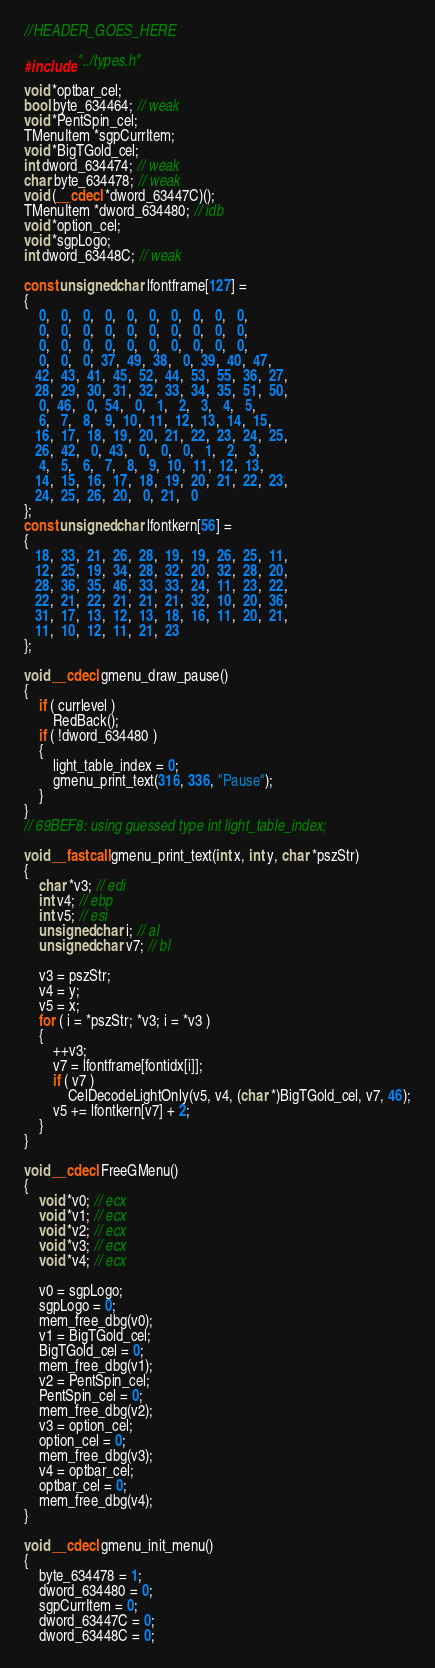<code> <loc_0><loc_0><loc_500><loc_500><_C++_>//HEADER_GOES_HERE

#include "../types.h"

void *optbar_cel;
bool byte_634464; // weak
void *PentSpin_cel;
TMenuItem *sgpCurrItem;
void *BigTGold_cel;
int dword_634474; // weak
char byte_634478; // weak
void (__cdecl *dword_63447C)();
TMenuItem *dword_634480; // idb
void *option_cel;
void *sgpLogo;
int dword_63448C; // weak

const unsigned char lfontframe[127] =
{
	0,   0,   0,   0,   0,   0,   0,   0,   0,   0,
	0,   0,   0,   0,   0,   0,   0,   0,   0,   0,
	0,   0,   0,   0,   0,   0,   0,   0,   0,   0,
	0,   0,   0,  37,  49,  38,   0,  39,  40,  47,
   42,  43,  41,  45,  52,  44,  53,  55,  36,  27,
   28,  29,  30,  31,  32,  33,  34,  35,  51,  50,
	0,  46,   0,  54,   0,   1,   2,   3,   4,   5,
	6,   7,   8,   9,  10,  11,  12,  13,  14,  15,
   16,  17,  18,  19,  20,  21,  22,  23,  24,  25,
   26,  42,   0,  43,   0,   0,   0,   1,   2,   3,
	4,   5,   6,   7,   8,   9,  10,  11,  12,  13,
   14,  15,  16,  17,  18,  19,  20,  21,  22,  23,
   24,  25,  26,  20,   0,  21,   0
};
const unsigned char lfontkern[56] =
{
   18,  33,  21,  26,  28,  19,  19,  26,  25,  11,
   12,  25,  19,  34,  28,  32,  20,  32,  28,  20,
   28,  36,  35,  46,  33,  33,  24,  11,  23,  22,
   22,  21,  22,  21,  21,  21,  32,  10,  20,  36,
   31,  17,  13,  12,  13,  18,  16,  11,  20,  21,
   11,  10,  12,  11,  21,  23
};

void __cdecl gmenu_draw_pause()
{
	if ( currlevel )
		RedBack();
	if ( !dword_634480 )
	{
		light_table_index = 0;
		gmenu_print_text(316, 336, "Pause");
	}
}
// 69BEF8: using guessed type int light_table_index;

void __fastcall gmenu_print_text(int x, int y, char *pszStr)
{
	char *v3; // edi
	int v4; // ebp
	int v5; // esi
	unsigned char i; // al
	unsigned char v7; // bl

	v3 = pszStr;
	v4 = y;
	v5 = x;
	for ( i = *pszStr; *v3; i = *v3 )
	{
		++v3;
		v7 = lfontframe[fontidx[i]];
		if ( v7 )
			CelDecodeLightOnly(v5, v4, (char *)BigTGold_cel, v7, 46);
		v5 += lfontkern[v7] + 2;
	}
}

void __cdecl FreeGMenu()
{
	void *v0; // ecx
	void *v1; // ecx
	void *v2; // ecx
	void *v3; // ecx
	void *v4; // ecx

	v0 = sgpLogo;
	sgpLogo = 0;
	mem_free_dbg(v0);
	v1 = BigTGold_cel;
	BigTGold_cel = 0;
	mem_free_dbg(v1);
	v2 = PentSpin_cel;
	PentSpin_cel = 0;
	mem_free_dbg(v2);
	v3 = option_cel;
	option_cel = 0;
	mem_free_dbg(v3);
	v4 = optbar_cel;
	optbar_cel = 0;
	mem_free_dbg(v4);
}

void __cdecl gmenu_init_menu()
{
	byte_634478 = 1;
	dword_634480 = 0;
	sgpCurrItem = 0;
	dword_63447C = 0;
	dword_63448C = 0;</code> 